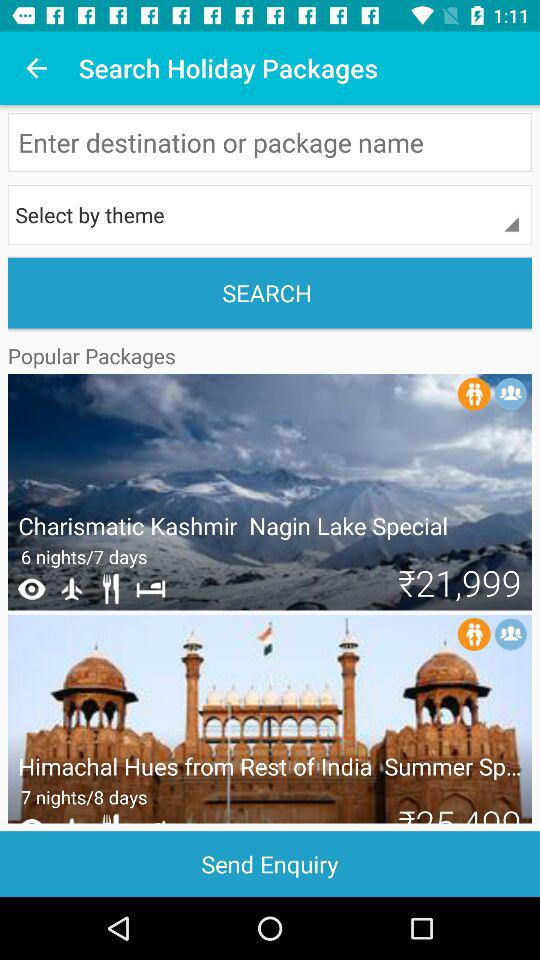Which package includes a 7-nights/8-days trip? The package that includes a 7-nights/8-days trip is "Himachal Hues from Rest of India Summer Sp...". 